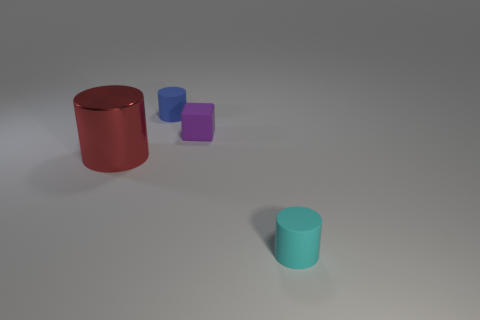Subtract all cyan cylinders. How many cylinders are left? 2 Subtract all gray cylinders. Subtract all cyan cubes. How many cylinders are left? 3 Add 3 big red cylinders. How many objects exist? 7 Subtract all blocks. How many objects are left? 3 Subtract all cyan matte cylinders. Subtract all red shiny objects. How many objects are left? 2 Add 1 red things. How many red things are left? 2 Add 3 big cylinders. How many big cylinders exist? 4 Subtract 0 brown cylinders. How many objects are left? 4 